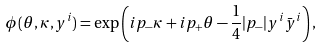<formula> <loc_0><loc_0><loc_500><loc_500>\phi ( \theta , \kappa , y ^ { i } ) = \exp \left ( i p _ { - } \kappa + i p _ { + } \theta - \frac { 1 } { 4 } | p _ { - } | y ^ { i } \bar { y } ^ { i } \right ) ,</formula> 